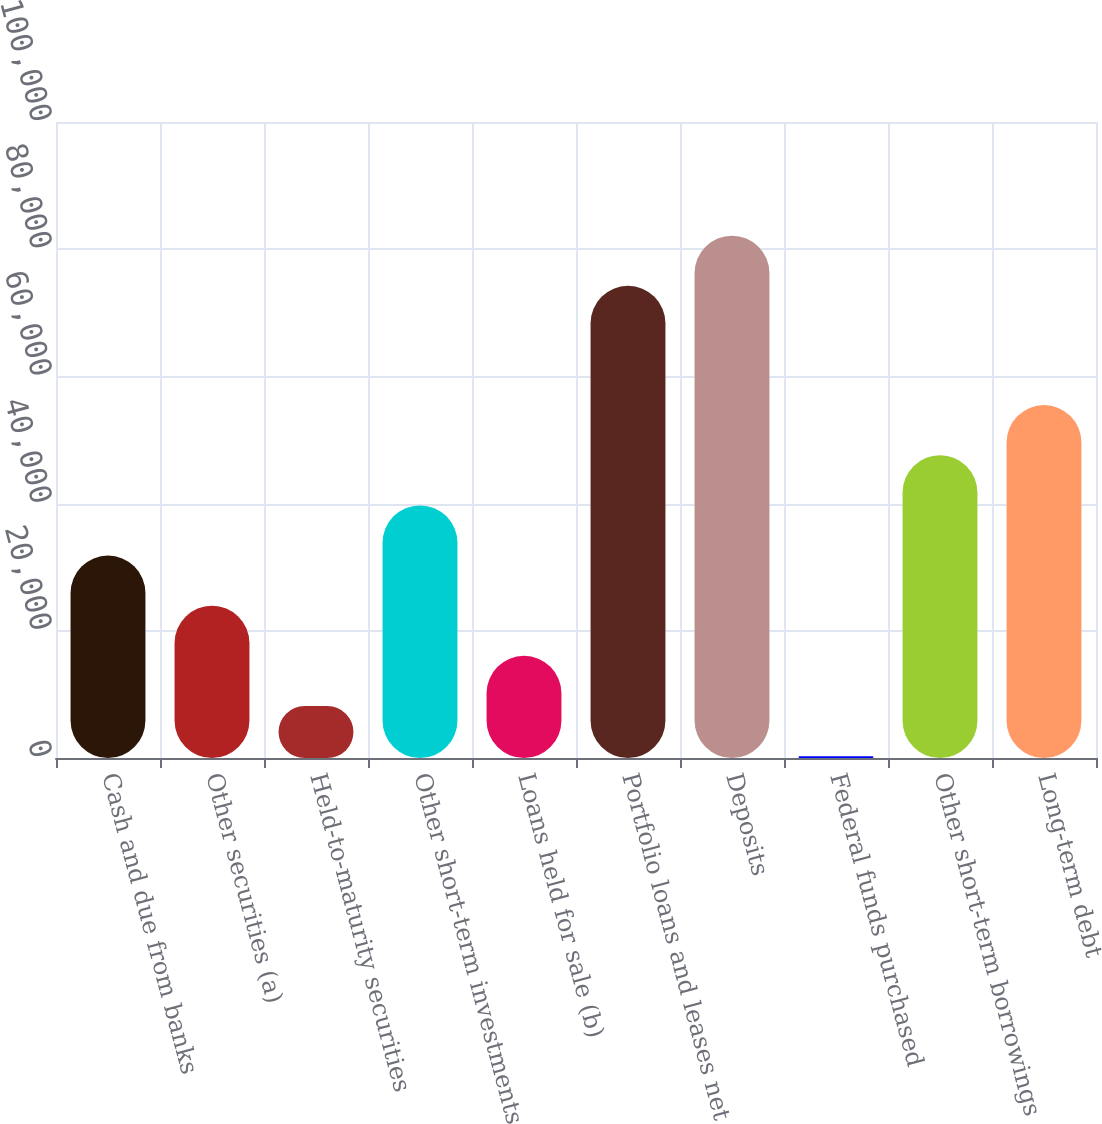<chart> <loc_0><loc_0><loc_500><loc_500><bar_chart><fcel>Cash and due from banks<fcel>Other securities (a)<fcel>Held-to-maturity securities<fcel>Other short-term investments<fcel>Loans held for sale (b)<fcel>Portfolio loans and leases net<fcel>Deposits<fcel>Federal funds purchased<fcel>Other short-term borrowings<fcel>Long-term debt<nl><fcel>31830.2<fcel>23944.4<fcel>8172.8<fcel>39716<fcel>16058.6<fcel>74234<fcel>82119.8<fcel>287<fcel>47601.8<fcel>55487.6<nl></chart> 